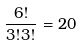Convert formula to latex. <formula><loc_0><loc_0><loc_500><loc_500>\frac { 6 ! } { 3 ! 3 ! } = 2 0</formula> 